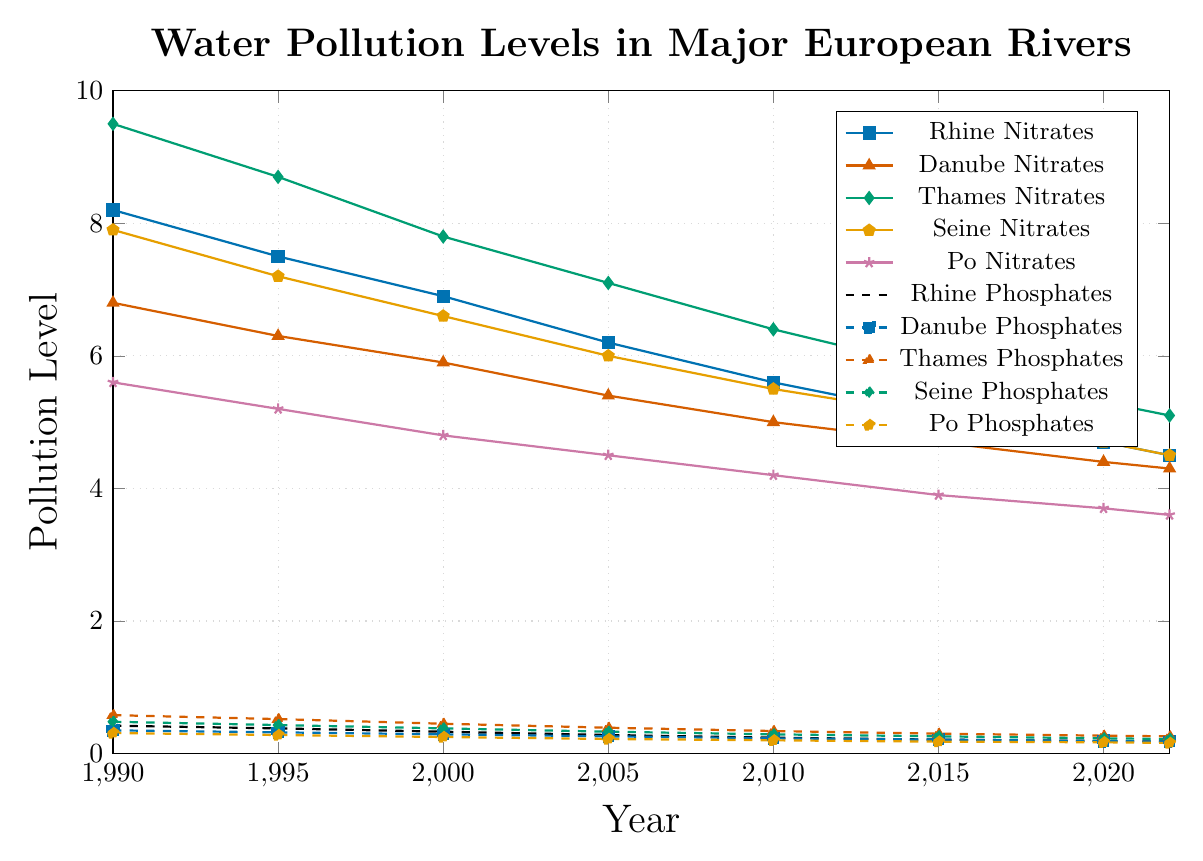What year saw the highest level of nitrates in the Thames? According to the figure, the highest level of nitrates in the Thames occurred in 1990 where the value was the greatest.
Answer: 1990 Which river had the lowest phosphate levels in 2022? From the figure, the phosphate levels in 2022 are represented by different dashed lines. The Po river had the lowest phosphate level in 2022.
Answer: Po How much did the nitrate levels decrease in the Rhine from 1990 to 2022? The nitrate levels in the Rhine in 1990 were 8.2 and in 2022 were 4.5. The decrease can be calculated as 8.2 - 4.5.
Answer: 3.7 Compare the phosphate levels of the Seine and Po rivers in 2010, which was higher? Observing the figure's dashed lines for 2010, the Seine had a phosphate level of 0.29, whereas the Po had a level of 0.20. Thus, the Seine had higher phosphate levels in 2010.
Answer: Seine What is the average phosphate level for the Danube river from 1990 to 2022? The phosphate levels for the Danube from 1990 to 2022 are 0.35, 0.32, 0.29, 0.26, 0.23, 0.21, 0.19, and 0.18. Summing these values gives 2.03. Dividing by 8 (number of years) gives an average of \( \frac{2.03}{8} \approx 0.254 \).
Answer: 0.254 Which river had the most significant decrease in nitrates from 1990 to 2022? Calculating the decrease for each river:
- Rhine: 8.2 to 4.5, decrease = 8.2 - 4.5 = 3.7
- Danube: 6.8 to 4.3, decrease = 6.8 - 4.3 = 2.5
- Thames: 9.5 to 5.1, decrease = 9.5 - 5.1 = 4.4
- Seine: 7.9 to 4.5, decrease = 7.9 - 4.5 = 3.4
- Po: 5.6 to 3.6, decrease = 5.6 - 3.6 = 2.0
The Thames had the most significant decrease.
Answer: Thames Between 2010 and 2015, did phosphate levels in the Rhine increase or decrease, and by how much? From the figure, the phosphate levels in the Rhine in 2010 were 0.24, and in 2015 were 0.21. The decrease can be calculated as 0.24 - 0.21.
Answer: Decrease by 0.03 In 2020, did any river have nitrate levels higher than the Thames? The nitrate levels in the Thames in 2020 are 5.3. Comparing this value with others shown in the figure, no river had higher nitrate levels than the Thames in 2020.
Answer: No What general trend can be observed in the phosphate levels across all rivers from 1990 to 2022? Observing the dashed lines for all rivers across the years, there is a consistent trend of decreasing phosphate levels over time.
Answer: Decreasing trend 